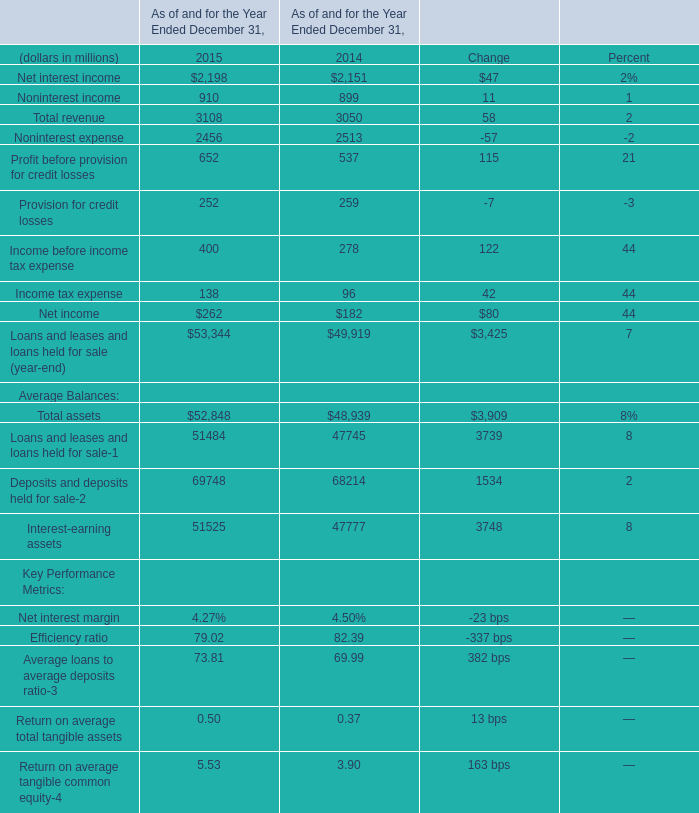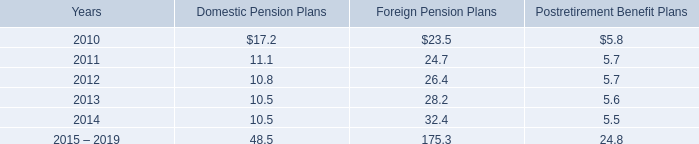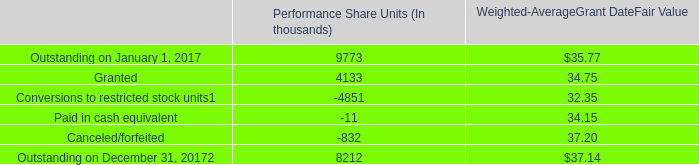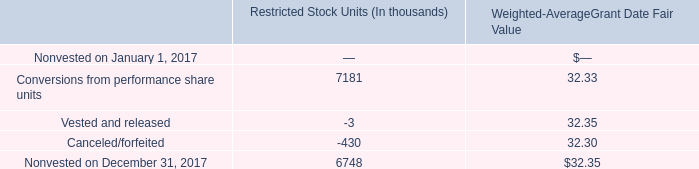What will Total revenue reach in 2016 if it continues to grow at its current rate? (in millions) 
Computations: ((1 + ((3108 - 3050) / 3050)) * 3108)
Answer: 3167.10295. 